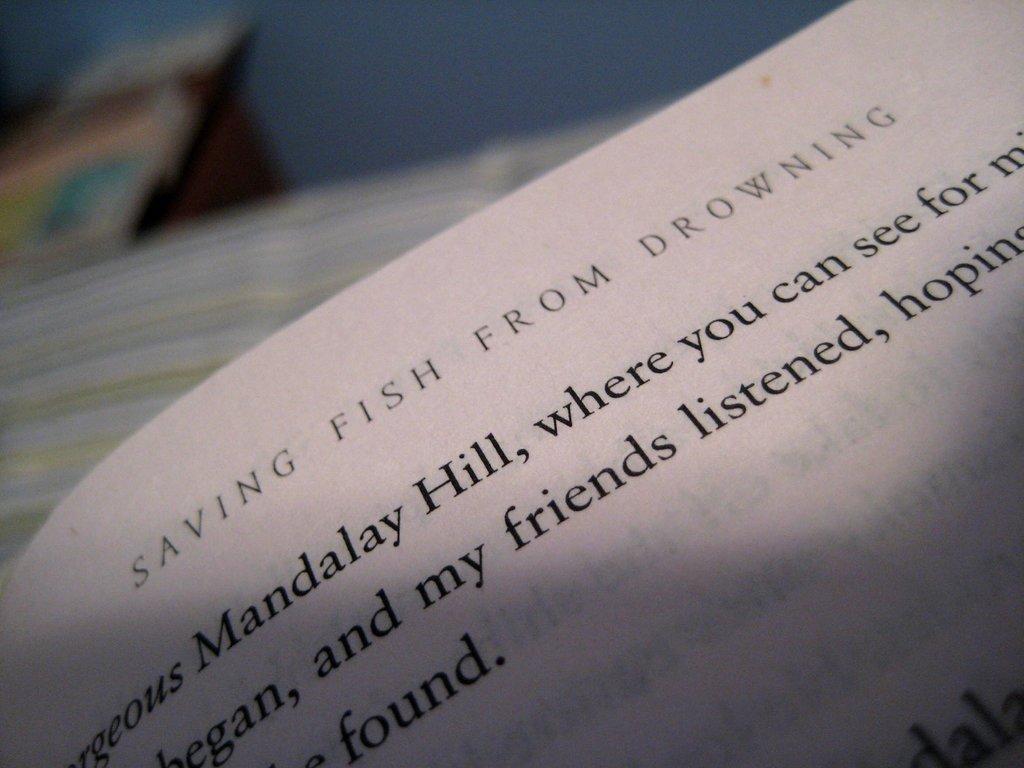Describe this image in one or two sentences. In the foreground, I can see a paper. The background is not clear. This picture might be taken in a room. 